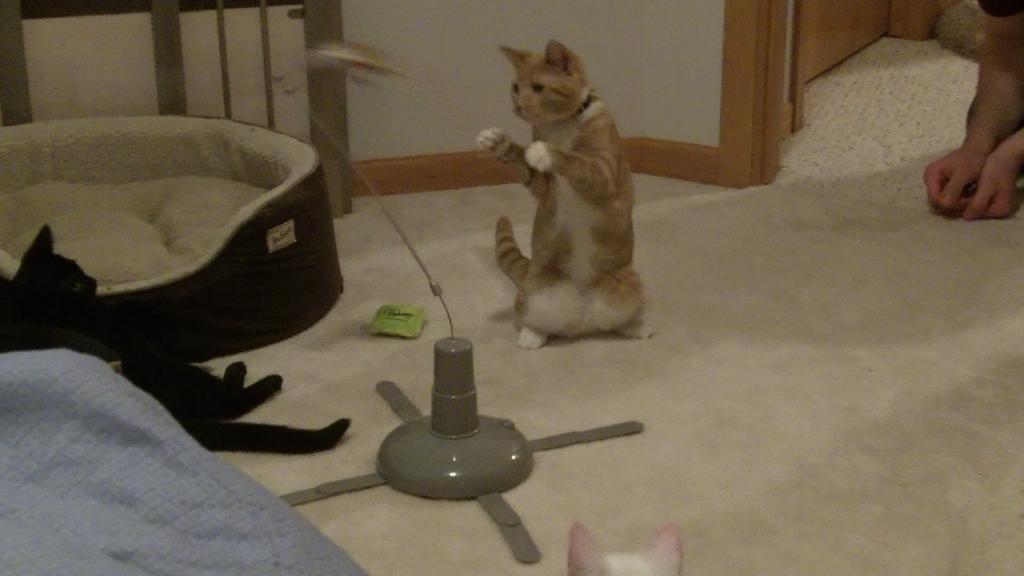How would you summarize this image in a sentence or two? In this image there are three cats, there are objects on the mat, there are objects truncated towards the left of the image, there is a wooden wall truncated towards the top of the image, there is a person truncated towards the right of the image. 